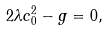Convert formula to latex. <formula><loc_0><loc_0><loc_500><loc_500>2 \lambda c _ { 0 } ^ { 2 } - g = 0 ,</formula> 